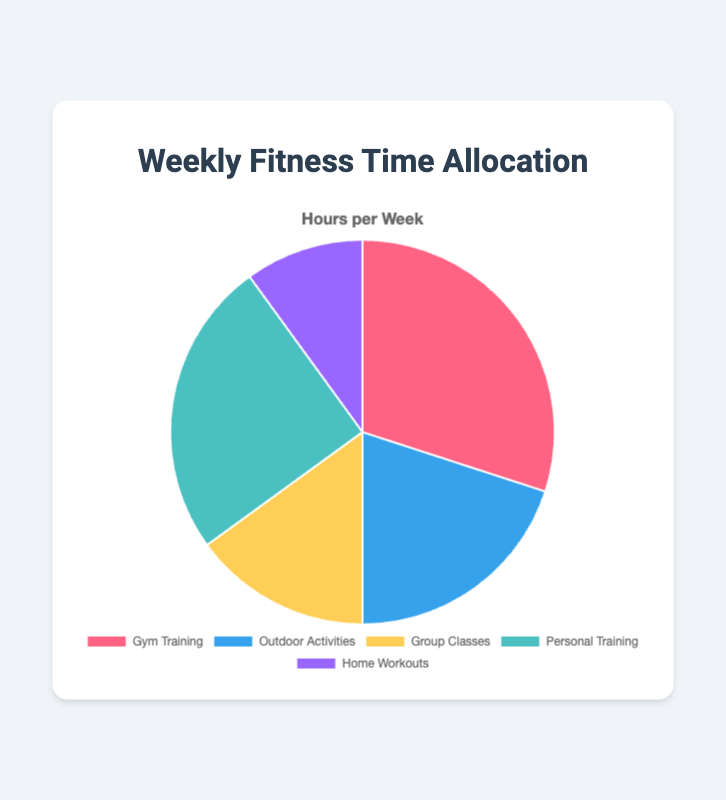What activity do people spend the most time on? By observing the chart, we can see that the largest segment, which represents Gym Training with 6 hours, is the most significant.
Answer: Gym Training What is the total time spent on Outdoor Activities and Group Classes? The chart shows that Outdoor Activities take 4 hours and Group Classes take 3 hours. Adding these together gives 4 + 3 = 7 hours.
Answer: 7 hours Which activity has the least time allocation? By looking at the smallest segment in the pie chart, we see that Home Workouts with 2 hours is the smallest.
Answer: Home Workouts How much more time is allocated to Personal Training compared to Home Workouts? Personal Training has 5 hours, and Home Workouts have 2 hours. The difference is 5 - 2 = 3 hours.
Answer: 3 hours What percentage of the total weekly time is spent on Group Classes? The total weekly time is the sum of all hours, which is 6 (Gym) + 4 (Outdoor) + 3 (Group) + 5 (Personal) + 2 (Home) = 20 hours. For Group Classes, the percentage is (3/20) * 100 = 15%.
Answer: 15% How does the time spent on Personal Training compare to Gym Training? Gym Training has the highest time allocation at 6 hours, while Personal Training has 5 hours. Personal Training is 1 hour less than Gym Training.
Answer: 1 hour less Which activity segment is represented by a green color in the pie chart? Observing the chart colors, the activity in green is Outdoor Activities.
Answer: Outdoor Activities What's the sum of hours allocated to activities outside the gym (Outdoor Activities and Home Workouts)? Outdoor Activities have 4 hours, and Home Workouts have 2 hours. Summing these gives 4 + 2 = 6 hours.
Answer: 6 hours If the time allocated to Gym Training was reduced by 2 hours and added to Home Workouts, how would the new time allocations look? Gym Training would become 6 - 2 = 4 hours and Home Workouts would become 2 + 2 = 4 hours. All other activities remain the same.
Answer: Gym Training: 4, Home Workouts: 4 